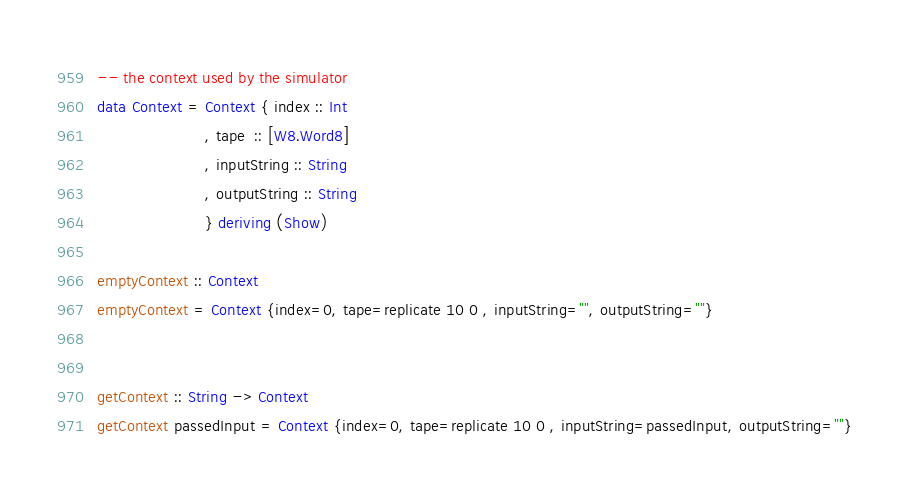<code> <loc_0><loc_0><loc_500><loc_500><_Haskell_>-- the context used by the simulator
data Context = Context { index :: Int         
                       , tape  :: [W8.Word8]
                       , inputString :: String
                       , outputString :: String 
                       } deriving (Show)

emptyContext :: Context
emptyContext = Context {index=0, tape=replicate 10 0 , inputString="", outputString=""}


getContext :: String -> Context
getContext passedInput = Context {index=0, tape=replicate 10 0 , inputString=passedInput, outputString=""}</code> 